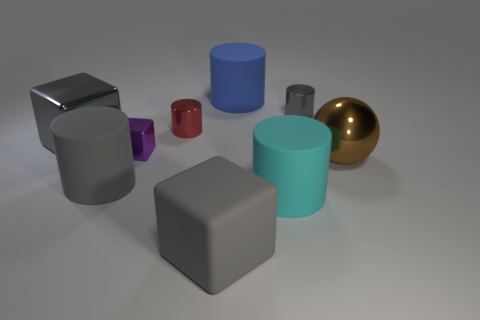Subtract all tiny metal cubes. How many cubes are left? 2 Add 1 large metal cubes. How many objects exist? 10 Subtract all blue cylinders. How many cylinders are left? 4 Subtract 1 cubes. How many cubes are left? 2 Subtract all gray spheres. Subtract all cyan blocks. How many spheres are left? 1 Subtract all gray balls. How many gray cylinders are left? 2 Subtract all matte things. Subtract all rubber blocks. How many objects are left? 4 Add 2 big gray cubes. How many big gray cubes are left? 4 Add 3 gray cylinders. How many gray cylinders exist? 5 Subtract 0 brown cylinders. How many objects are left? 9 